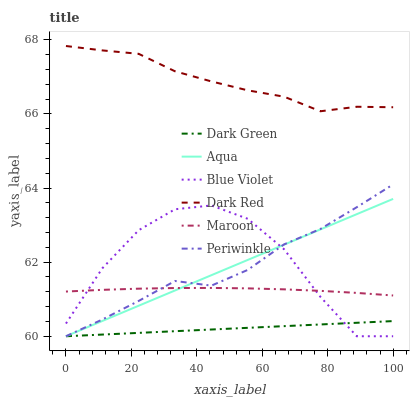Does Aqua have the minimum area under the curve?
Answer yes or no. No. Does Aqua have the maximum area under the curve?
Answer yes or no. No. Is Maroon the smoothest?
Answer yes or no. No. Is Maroon the roughest?
Answer yes or no. No. Does Maroon have the lowest value?
Answer yes or no. No. Does Aqua have the highest value?
Answer yes or no. No. Is Maroon less than Dark Red?
Answer yes or no. Yes. Is Maroon greater than Dark Green?
Answer yes or no. Yes. Does Maroon intersect Dark Red?
Answer yes or no. No. 